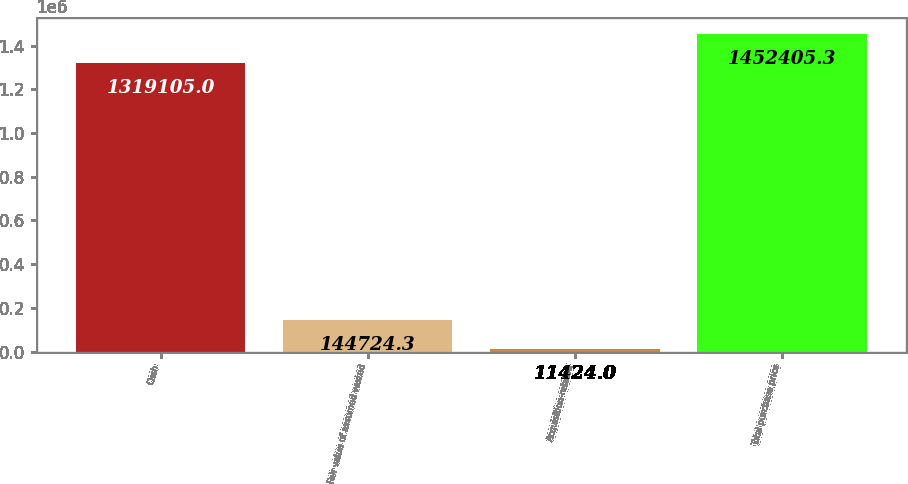Convert chart to OTSL. <chart><loc_0><loc_0><loc_500><loc_500><bar_chart><fcel>Cash<fcel>Fair value of assumed vested<fcel>Acquisition-related<fcel>Total purchase price<nl><fcel>1.3191e+06<fcel>144724<fcel>11424<fcel>1.45241e+06<nl></chart> 